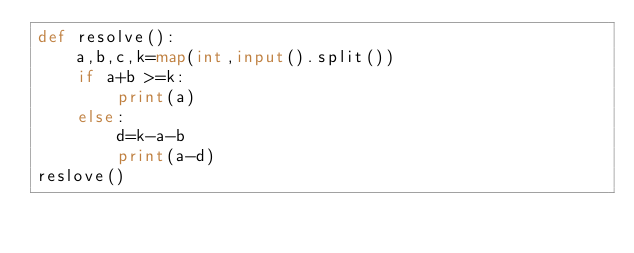Convert code to text. <code><loc_0><loc_0><loc_500><loc_500><_Python_>def resolve():
    a,b,c,k=map(int,input().split())
    if a+b >=k:
        print(a)
    else:
        d=k-a-b
        print(a-d)
reslove()</code> 